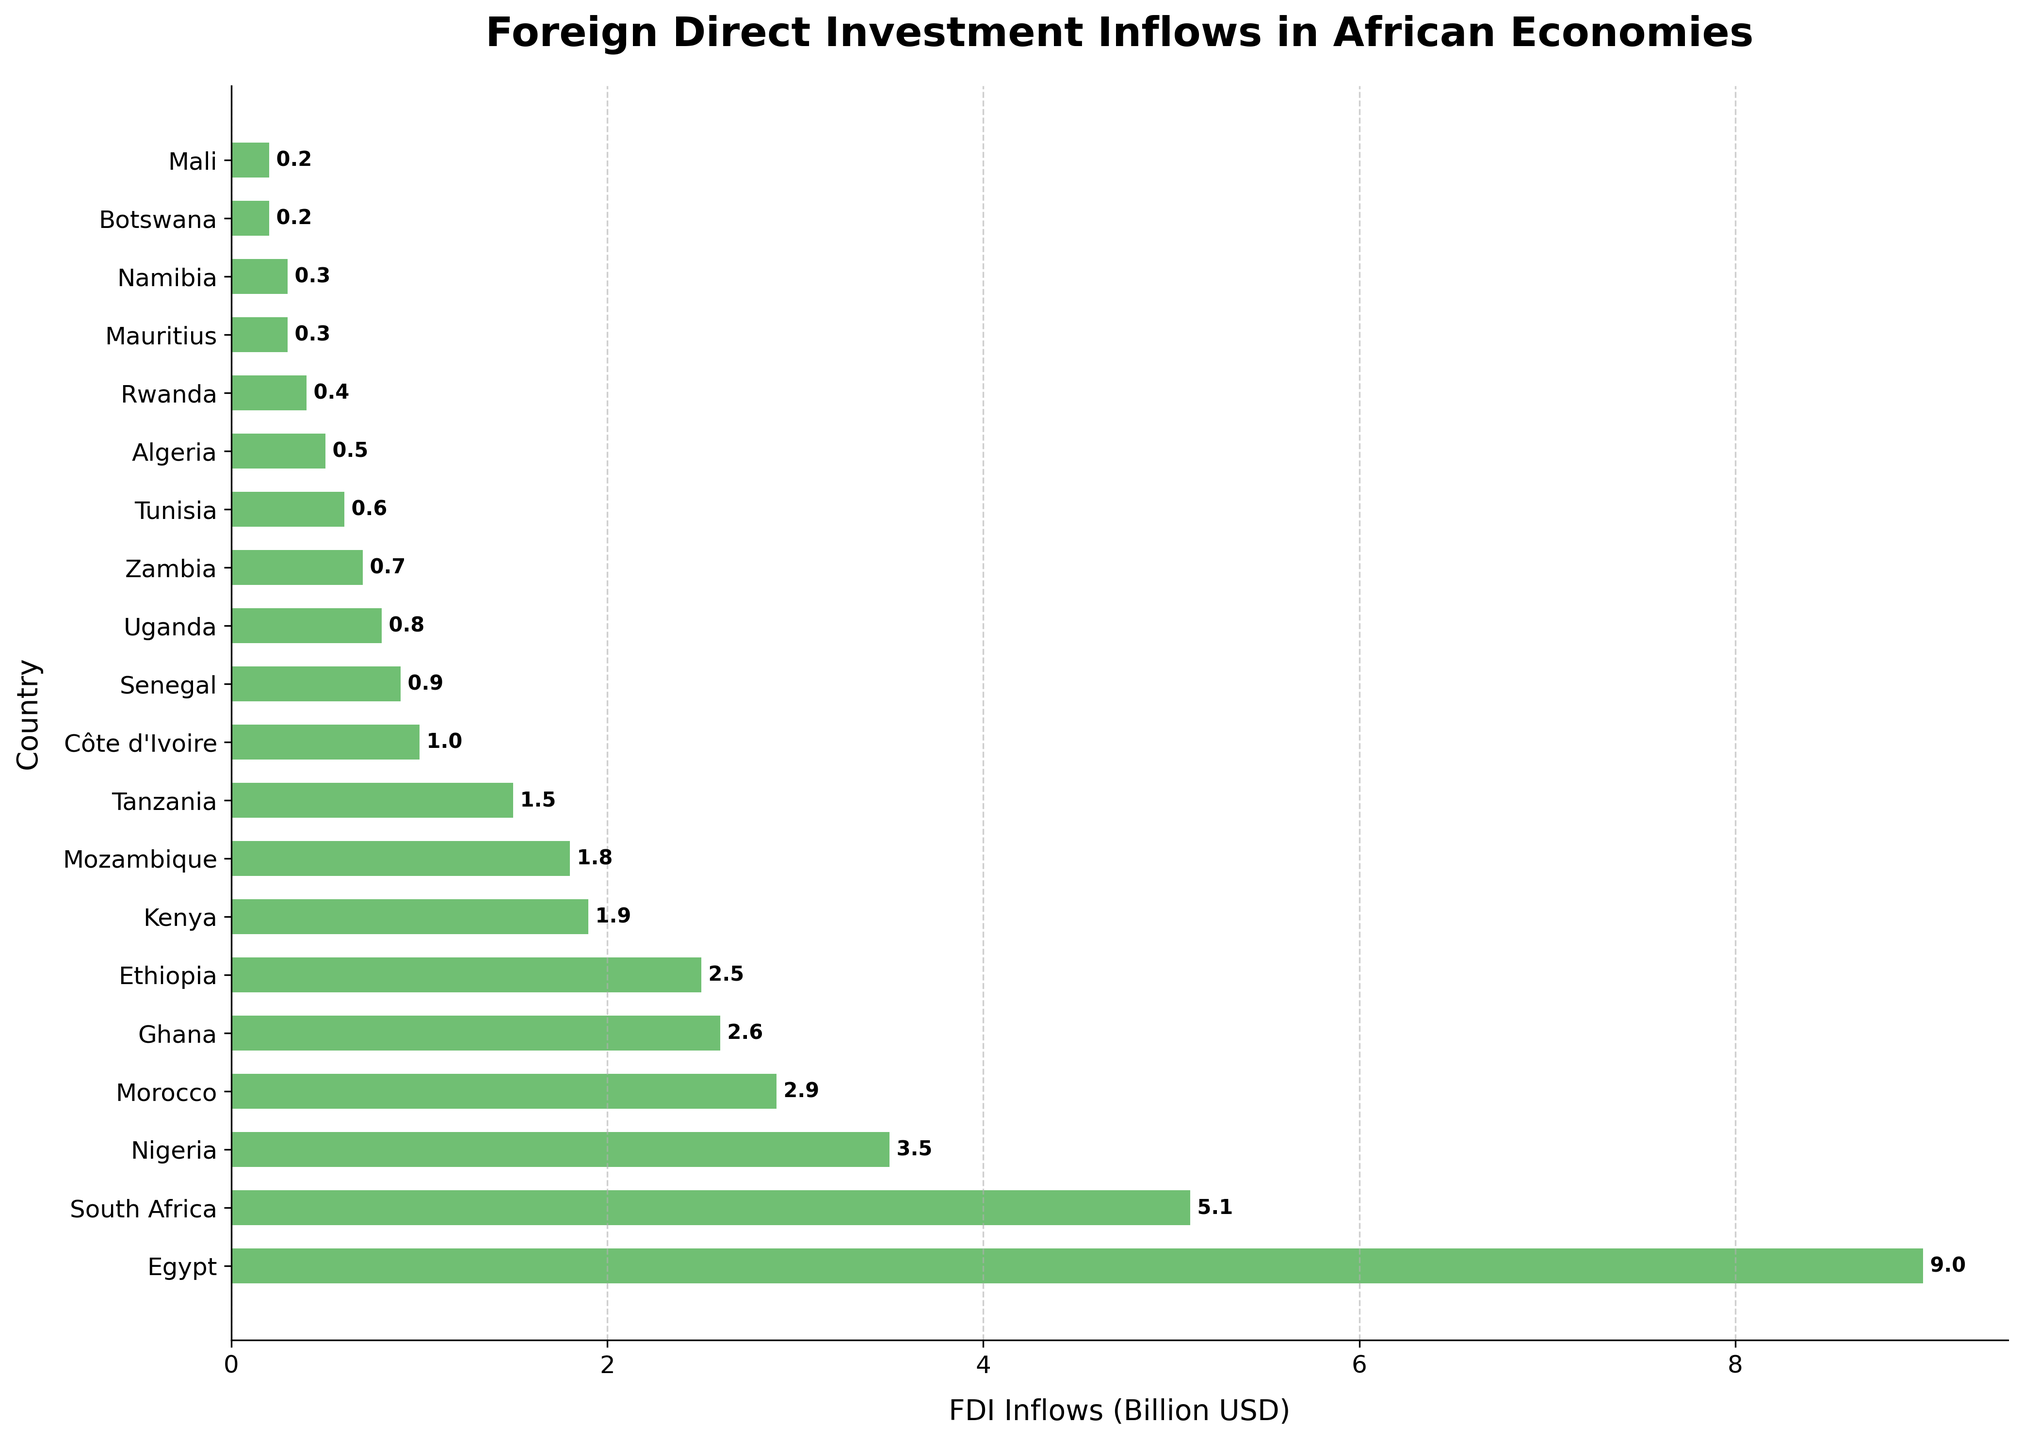Which country has the highest FDI inflows? By looking at the length of the bars, we can see that Egypt's bar is the longest, indicating it has the highest FDI inflows.
Answer: Egypt What is the total FDI inflows of the top three countries? The top three countries are Egypt, South Africa, and Nigeria. Summing their FDI inflows gives 9.0 + 5.1 + 3.5 = 17.6 billion USD.
Answer: 17.6 billion USD How much larger are FDI inflows in Egypt compared to Kenya? Egypt has FDI inflows of 9.0 billion USD and Kenya has 1.9 billion USD. The difference is 9.0 - 1.9 = 7.1 billion USD.
Answer: 7.1 billion USD Which country has the smallest FDI inflows, and what are those inflows? By looking at the shortest bar, we can see that Mali has the smallest FDI inflows of 0.2 billion USD.
Answer: Mali, 0.2 billion USD What is the average FDI inflows for the countries listed? To find the average, sum the FDI inflows of all countries and divide by the number of countries. Sum = 9.0 + 5.1 + 3.5 + 2.9 + 2.6 + 2.5 + 1.9 + 1.8 + 1.5 + 1.0 + 0.9 + 0.8 + 0.7 + 0.6 + 0.5 + 0.4 + 0.3 + 0.3 + 0.2 + 0.2 = 41.7 billion USD. There are 20 countries, so the average is 41.7 / 20 = 2.085 billion USD.
Answer: 2.085 billion USD How do the FDI inflows of Ethiopia and Zambia compare? Ethiopia has FDI inflows of 2.5 billion USD, while Zambia has 0.7 billion USD. Ethiopia's FDI inflows are larger.
Answer: Ethiopia What is the combined FDI inflows for Senegal, Uganda, and Zambia? Sum the FDI inflows of Senegal, Uganda, and Zambia: 0.9 + 0.8 + 0.7 = 2.4 billion USD.
Answer: 2.4 billion USD Is the FDI inflows of Mauritius greater than that of Namibia? Both Mauritius and Namibia have FDI inflows of 0.3 billion USD, so their inflows are equal.
Answer: Equal 